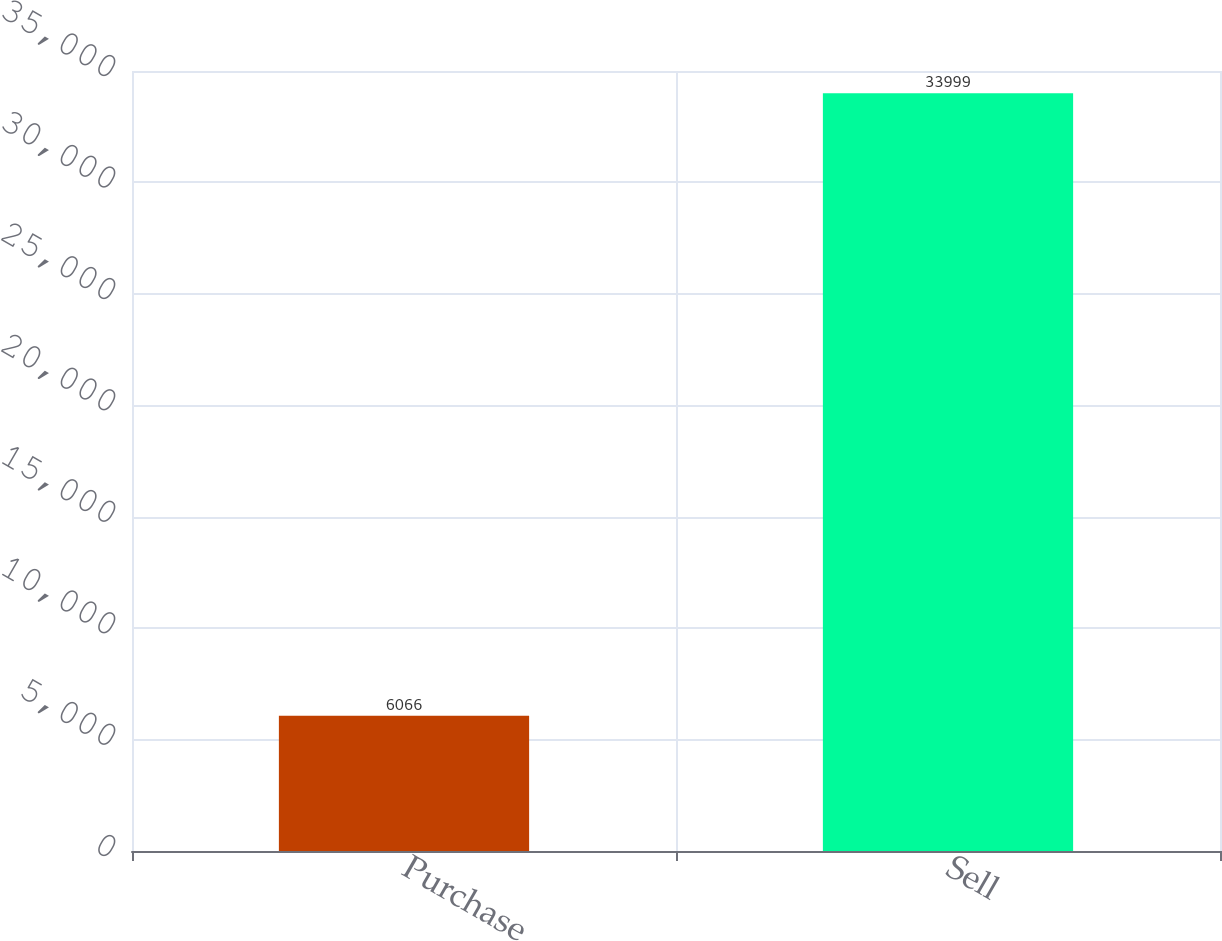Convert chart. <chart><loc_0><loc_0><loc_500><loc_500><bar_chart><fcel>Purchase<fcel>Sell<nl><fcel>6066<fcel>33999<nl></chart> 